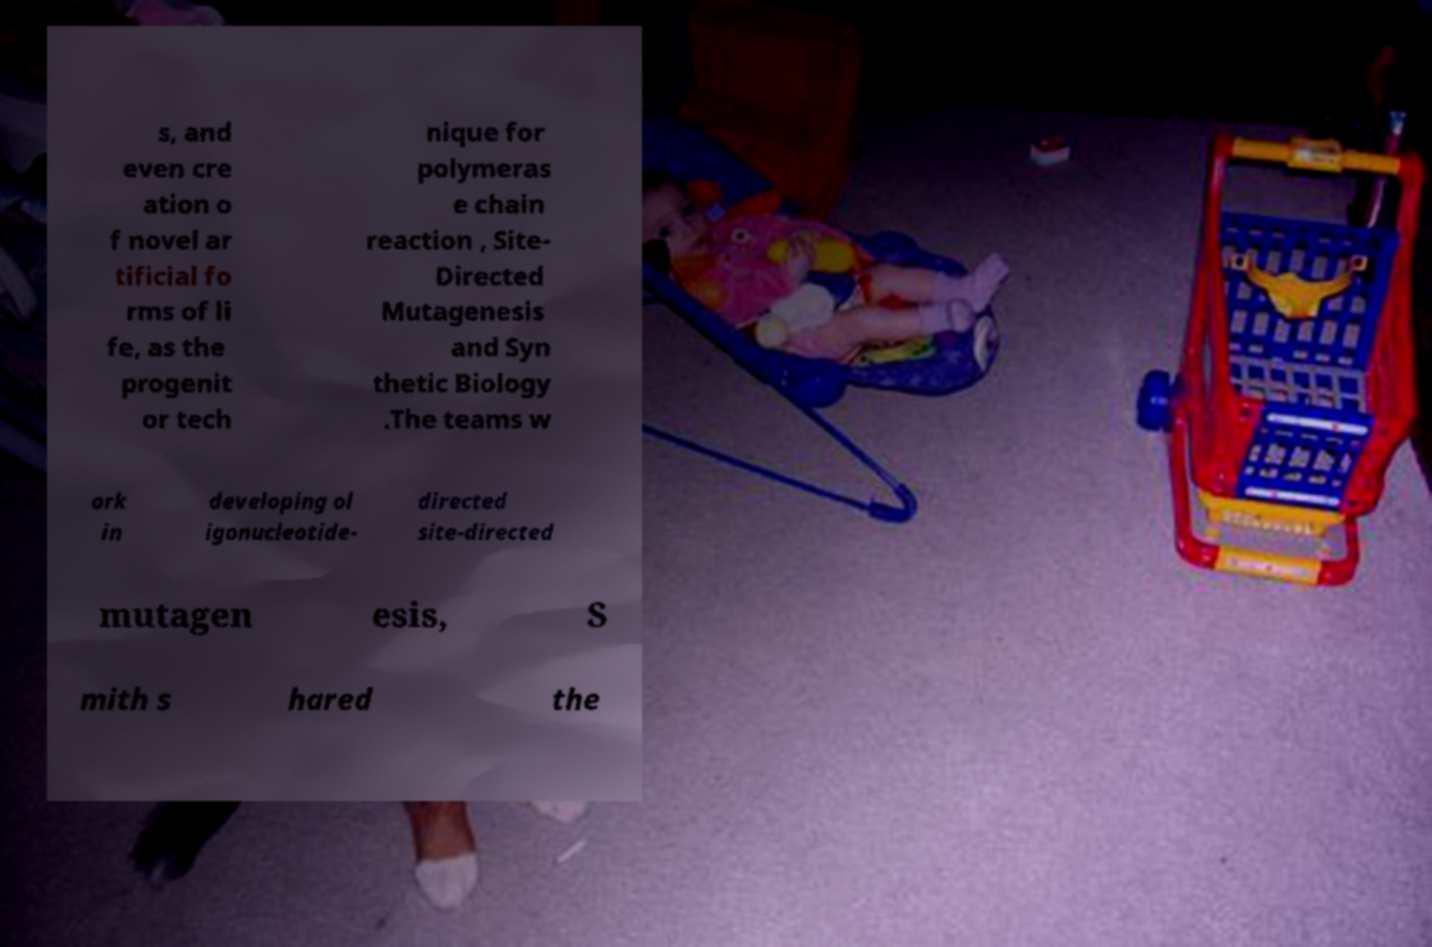Can you read and provide the text displayed in the image?This photo seems to have some interesting text. Can you extract and type it out for me? s, and even cre ation o f novel ar tificial fo rms of li fe, as the progenit or tech nique for polymeras e chain reaction , Site- Directed Mutagenesis and Syn thetic Biology .The teams w ork in developing ol igonucleotide- directed site-directed mutagen esis, S mith s hared the 